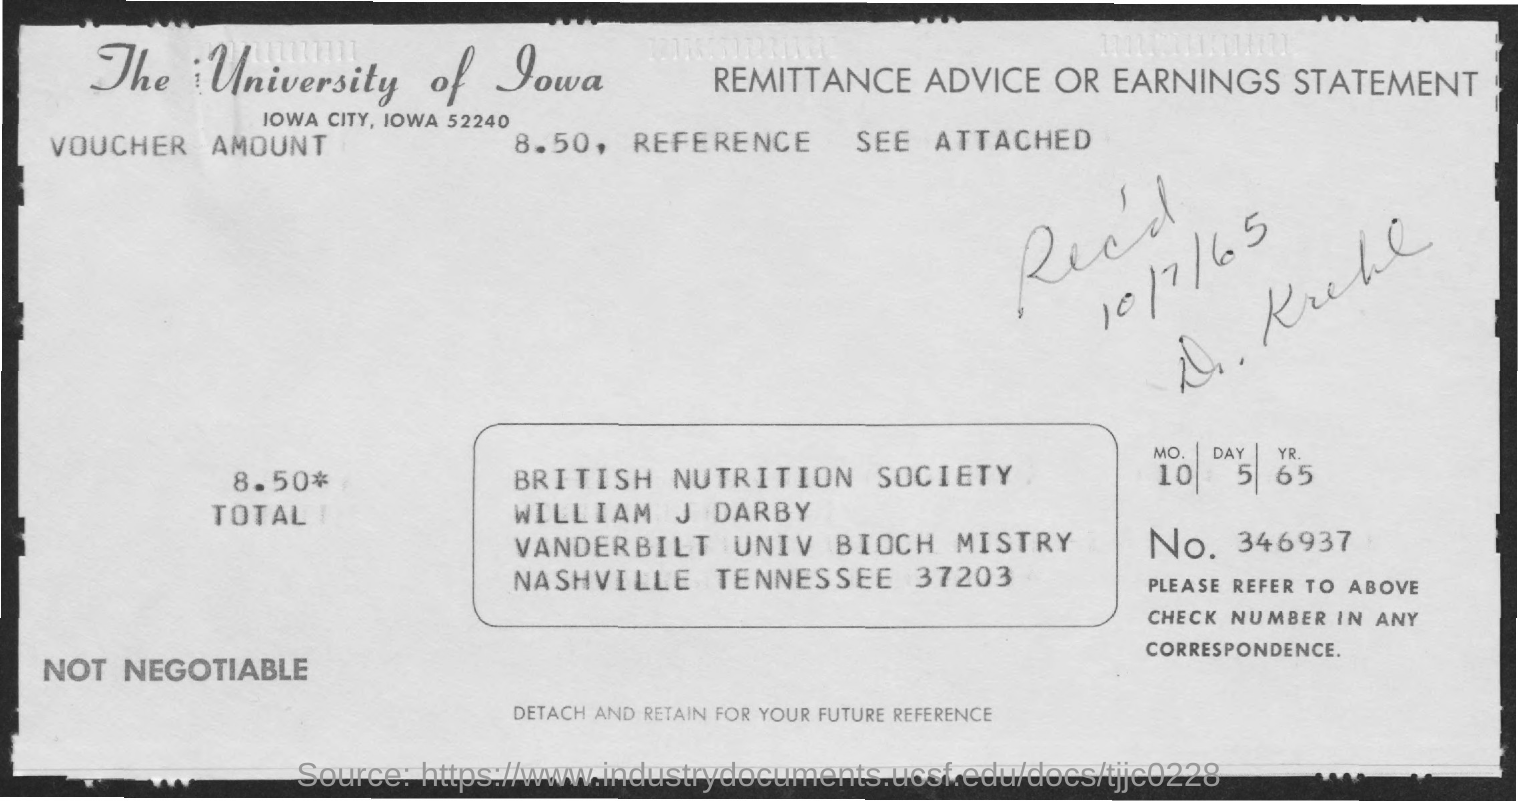Identify some key points in this picture. The header of the document mentions The University of Iowa. 